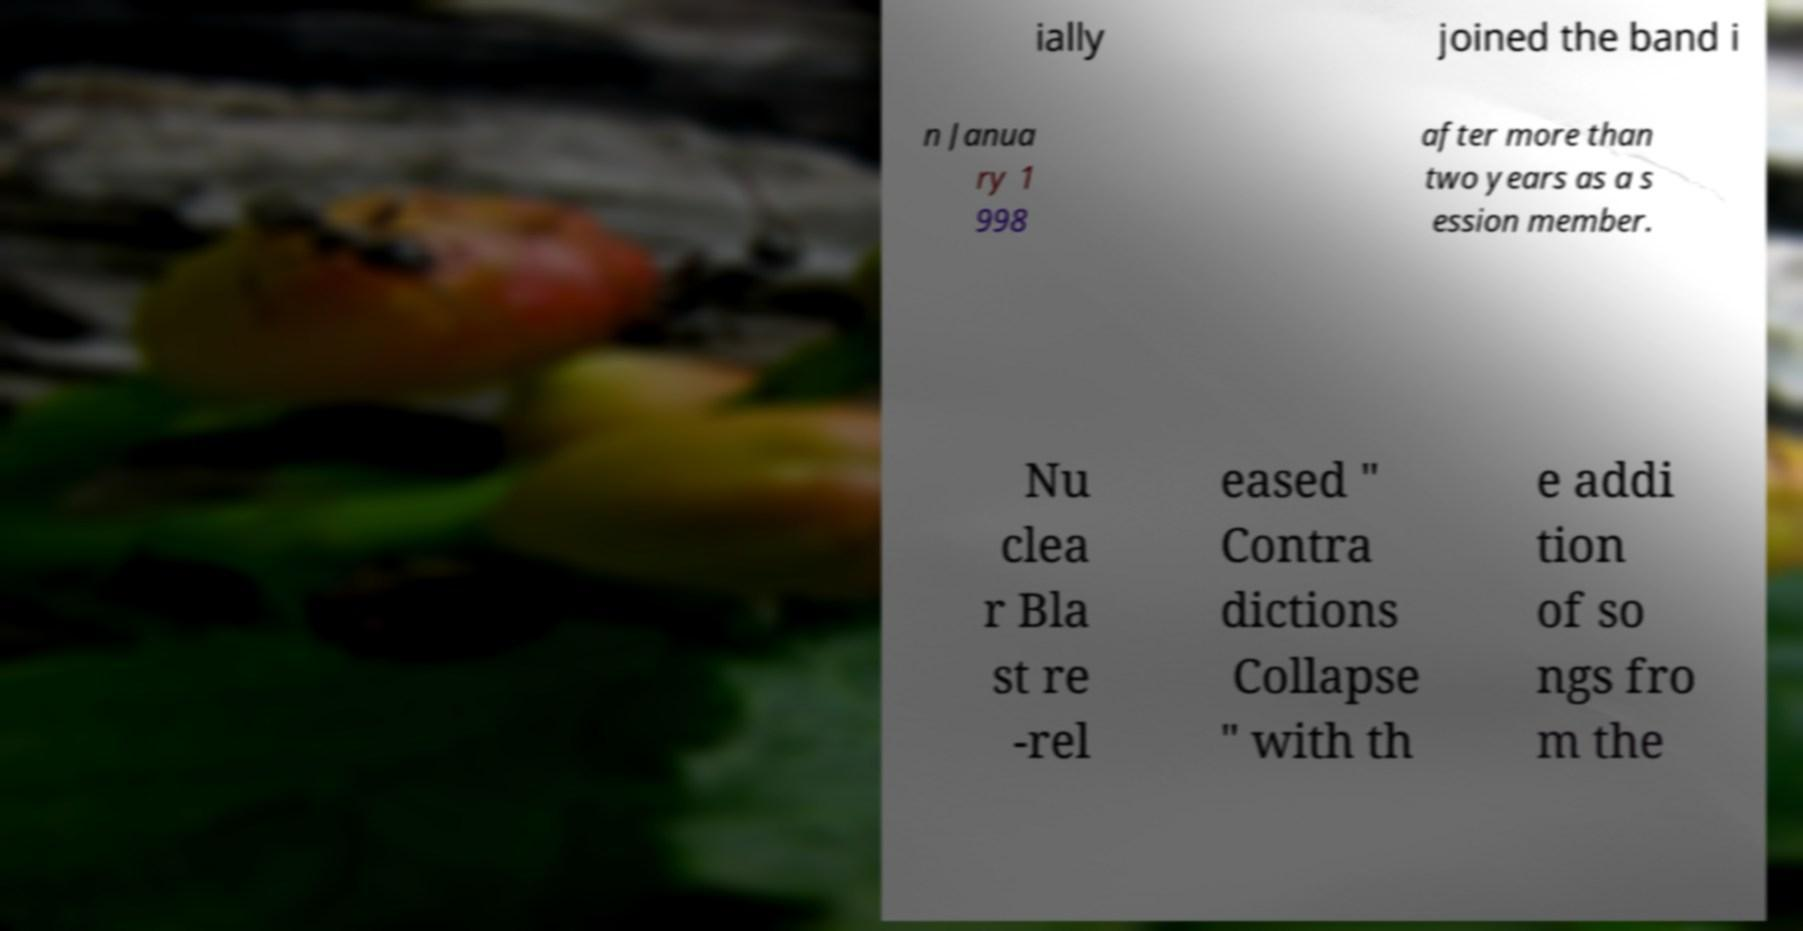What messages or text are displayed in this image? I need them in a readable, typed format. ially joined the band i n Janua ry 1 998 after more than two years as a s ession member. Nu clea r Bla st re -rel eased " Contra dictions Collapse " with th e addi tion of so ngs fro m the 